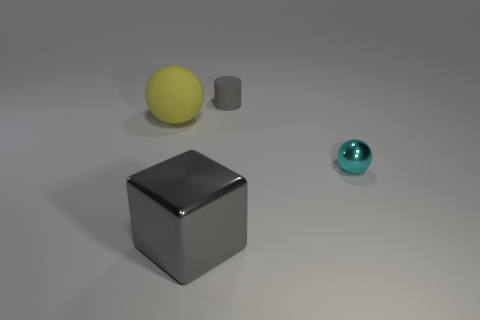What number of things are the same color as the tiny cylinder? None of the objects share the same color as the tiny cylinder, which displays a unique shade in the image. 